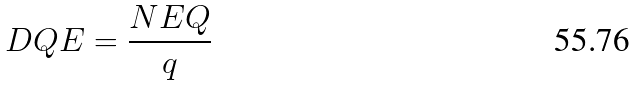<formula> <loc_0><loc_0><loc_500><loc_500>D Q E = \frac { N E Q } { q }</formula> 